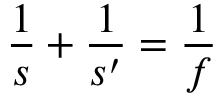Convert formula to latex. <formula><loc_0><loc_0><loc_500><loc_500>{ \frac { 1 } { s } } + { \frac { 1 } { s ^ { \prime } } } = { \frac { 1 } { f } }</formula> 